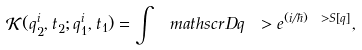<formula> <loc_0><loc_0><loc_500><loc_500>\mathcal { K } ( q ^ { i } _ { 2 } , t _ { 2 } ; q ^ { i } _ { 1 } , t _ { 1 } ) = \int \ m a t h s c r { D } q \ > e ^ { ( i / \hbar { ) } \ > S [ q ] } ,</formula> 